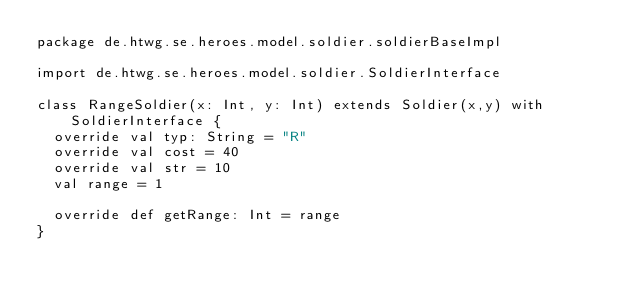Convert code to text. <code><loc_0><loc_0><loc_500><loc_500><_Scala_>package de.htwg.se.heroes.model.soldier.soldierBaseImpl

import de.htwg.se.heroes.model.soldier.SoldierInterface

class RangeSoldier(x: Int, y: Int) extends Soldier(x,y) with SoldierInterface {
  override val typ: String = "R"
  override val cost = 40
  override val str = 10
  val range = 1

  override def getRange: Int = range
}
</code> 